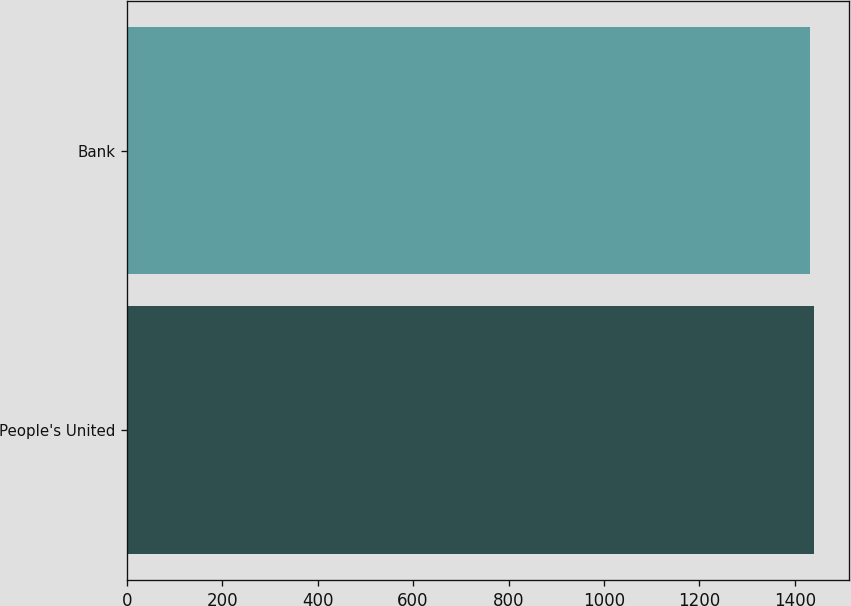Convert chart. <chart><loc_0><loc_0><loc_500><loc_500><bar_chart><fcel>People's United<fcel>Bank<nl><fcel>1440.6<fcel>1431.9<nl></chart> 